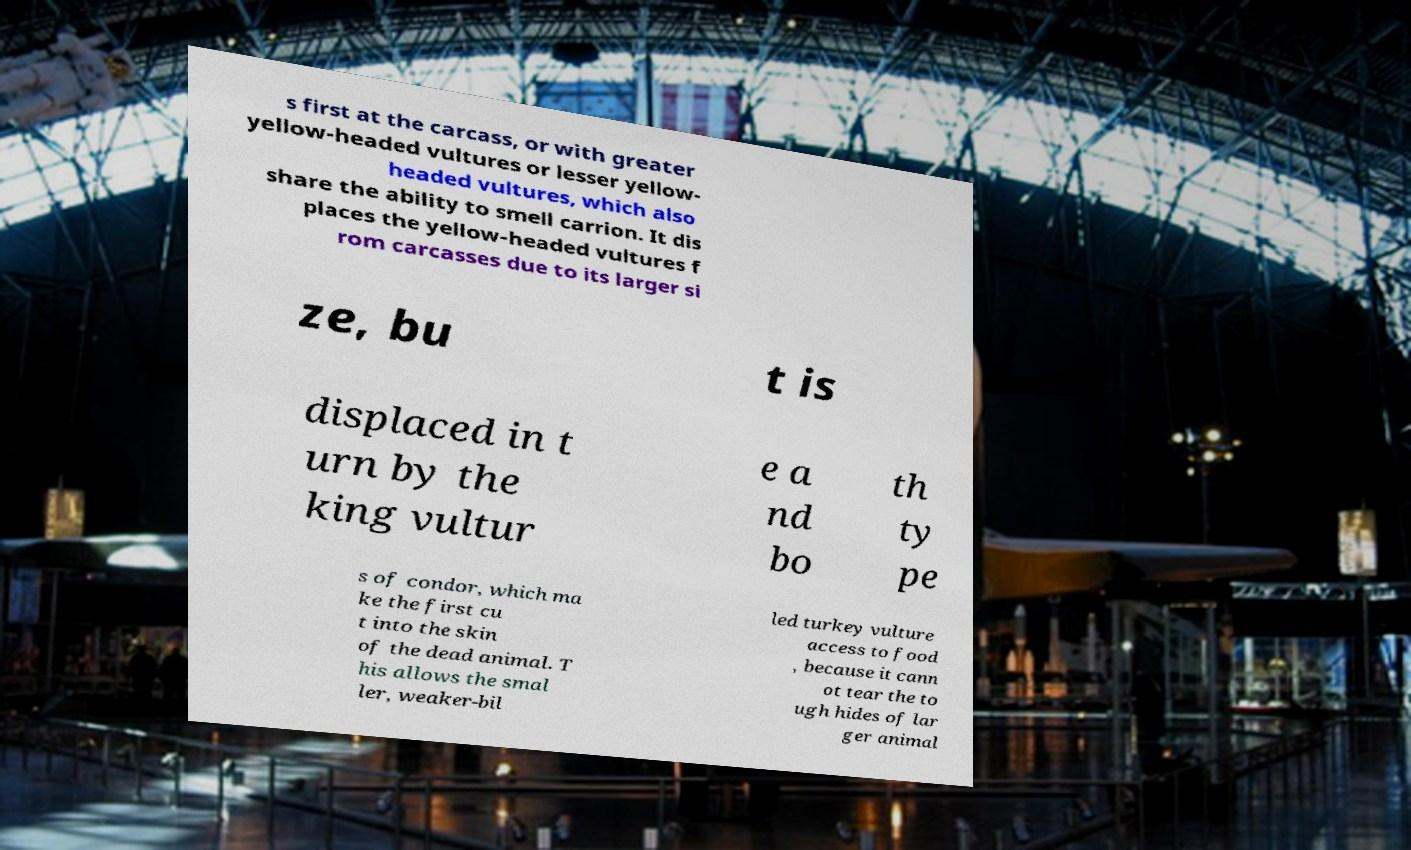For documentation purposes, I need the text within this image transcribed. Could you provide that? s first at the carcass, or with greater yellow-headed vultures or lesser yellow- headed vultures, which also share the ability to smell carrion. It dis places the yellow-headed vultures f rom carcasses due to its larger si ze, bu t is displaced in t urn by the king vultur e a nd bo th ty pe s of condor, which ma ke the first cu t into the skin of the dead animal. T his allows the smal ler, weaker-bil led turkey vulture access to food , because it cann ot tear the to ugh hides of lar ger animal 